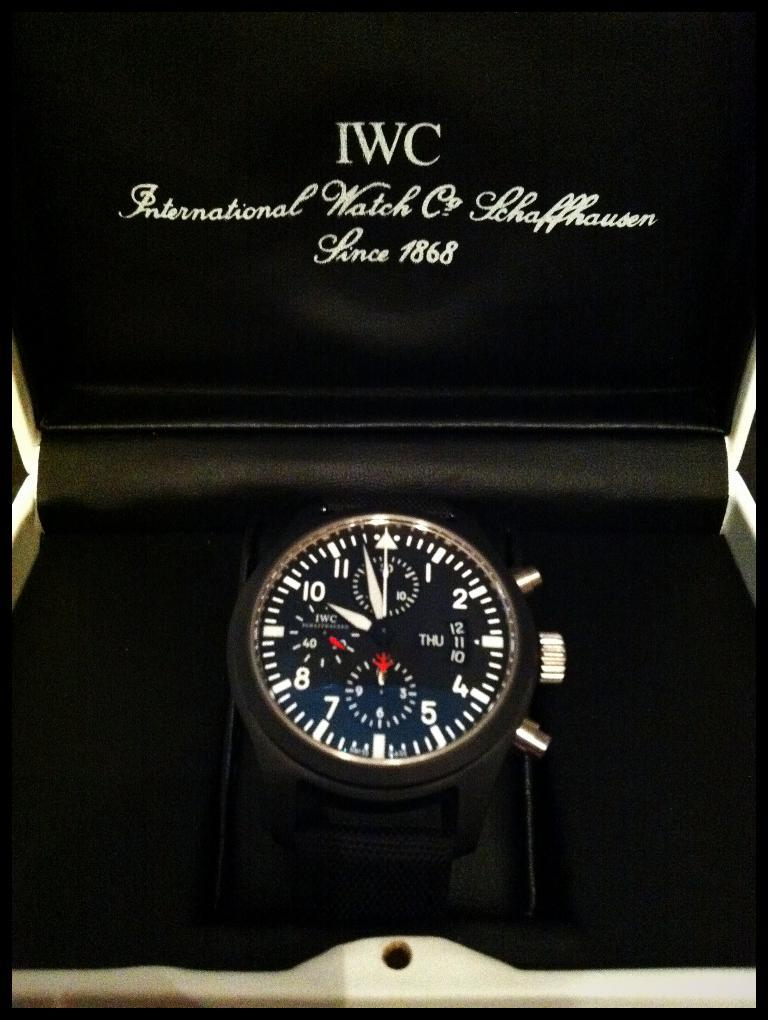<image>
Summarize the visual content of the image. A black watch in a black box and the box has the letters IWC on it. 